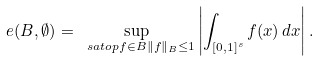<formula> <loc_0><loc_0><loc_500><loc_500>e ( B , \emptyset ) = \sup _ { \ s a t o p { f \in B } { \| f \| _ { B } \leq 1 } } \left | \int _ { [ 0 , 1 ] ^ { s } } f ( x ) \, d x \right | .</formula> 